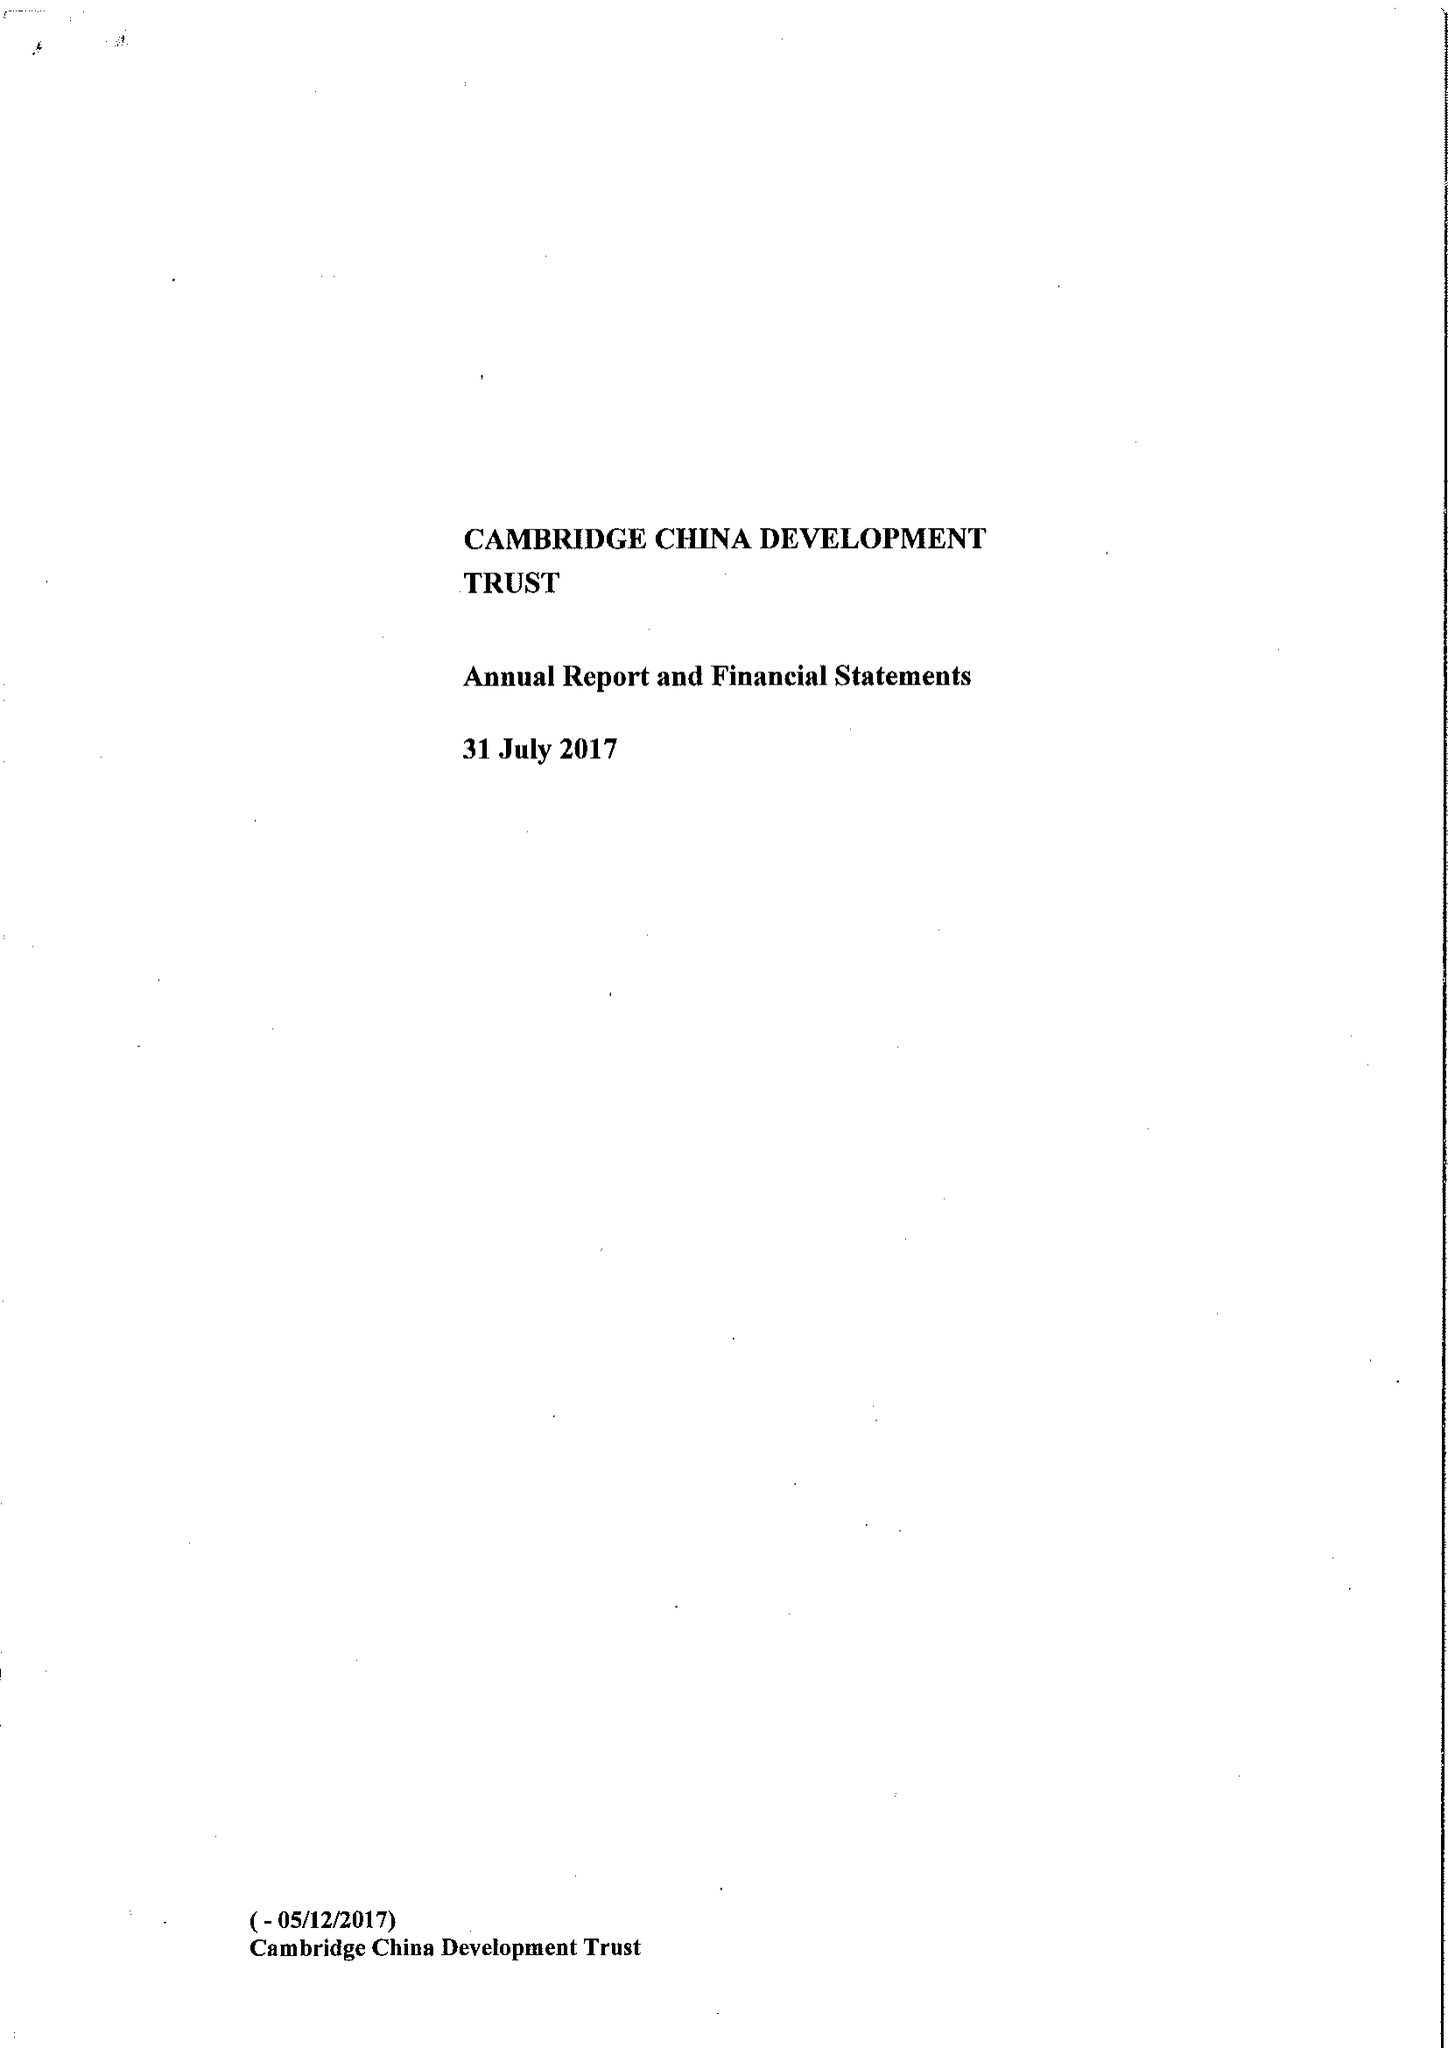What is the value for the address__street_line?
Answer the question using a single word or phrase. None 